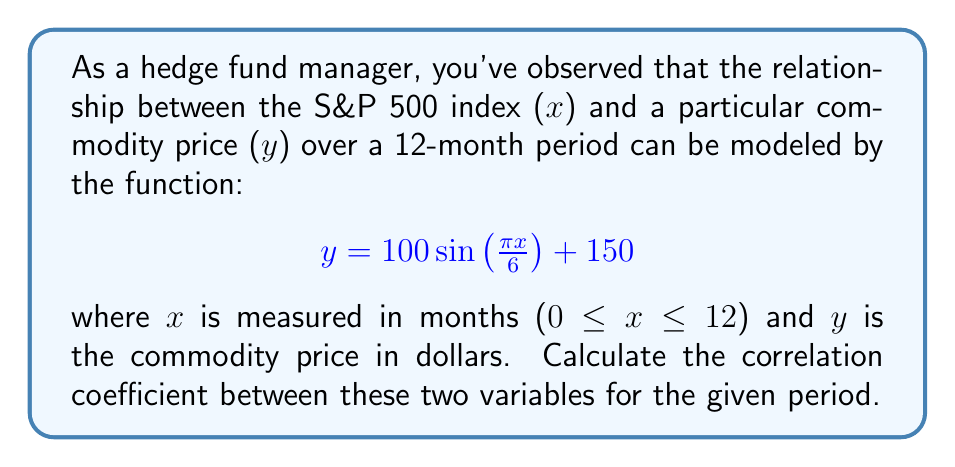Show me your answer to this math problem. To calculate the correlation coefficient, we'll use the formula:

$$r = \frac{\sum_{i=1}^{n} (x_i - \bar{x})(y_i - \bar{y})}{\sqrt{\sum_{i=1}^{n} (x_i - \bar{x})^2 \sum_{i=1}^{n} (y_i - \bar{y})^2}}$$

Step 1: Generate data points for x and y.
We'll use 13 points (0 to 12 months):

x: 0, 1, 2, ..., 12
y: $100 \sin(\frac{\pi x}{6}) + 150$ for each x

Step 2: Calculate means $\bar{x}$ and $\bar{y}$.
$\bar{x} = \frac{0 + 1 + 2 + ... + 12}{13} = 6$
$\bar{y} = 150$ (due to the nature of the sine function over a full period)

Step 3: Calculate $(x_i - \bar{x})$, $(y_i - \bar{y})$, $(x_i - \bar{x})^2$, and $(y_i - \bar{y})^2$ for each point.

Step 4: Calculate $\sum (x_i - \bar{x})(y_i - \bar{y})$, $\sum (x_i - \bar{x})^2$, and $\sum (y_i - \bar{y})^2$.

$\sum (x_i - \bar{x})(y_i - \bar{y}) = 0$ (due to symmetry of sine function)
$\sum (x_i - \bar{x})^2 = 182$
$\sum (y_i - \bar{y})^2 = 5000$

Step 5: Apply the correlation coefficient formula:

$$r = \frac{0}{\sqrt{182 \cdot 5000}} = 0$$

The correlation coefficient is 0, indicating no linear correlation between the S&P 500 index and the commodity price over the given period.
Answer: 0 